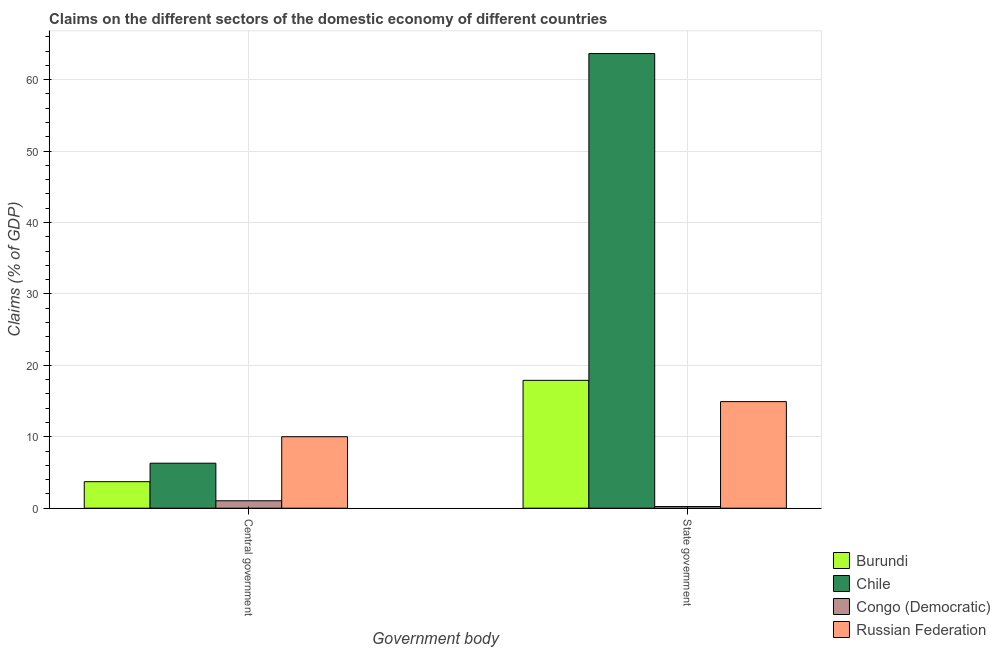How many different coloured bars are there?
Offer a terse response. 4. How many groups of bars are there?
Give a very brief answer. 2. Are the number of bars per tick equal to the number of legend labels?
Provide a short and direct response. Yes. How many bars are there on the 1st tick from the left?
Keep it short and to the point. 4. What is the label of the 1st group of bars from the left?
Ensure brevity in your answer.  Central government. What is the claims on central government in Burundi?
Offer a terse response. 3.71. Across all countries, what is the maximum claims on central government?
Offer a terse response. 10.01. Across all countries, what is the minimum claims on central government?
Give a very brief answer. 1.04. In which country was the claims on central government maximum?
Keep it short and to the point. Russian Federation. In which country was the claims on state government minimum?
Ensure brevity in your answer.  Congo (Democratic). What is the total claims on central government in the graph?
Ensure brevity in your answer.  21.06. What is the difference between the claims on state government in Chile and that in Congo (Democratic)?
Your answer should be very brief. 63.41. What is the difference between the claims on state government in Russian Federation and the claims on central government in Burundi?
Give a very brief answer. 11.21. What is the average claims on state government per country?
Provide a short and direct response. 24.17. What is the difference between the claims on central government and claims on state government in Chile?
Offer a very short reply. -57.34. What is the ratio of the claims on central government in Russian Federation to that in Chile?
Your answer should be very brief. 1.59. In how many countries, is the claims on state government greater than the average claims on state government taken over all countries?
Give a very brief answer. 1. What does the 3rd bar from the left in Central government represents?
Offer a very short reply. Congo (Democratic). What does the 3rd bar from the right in Central government represents?
Offer a very short reply. Chile. Does the graph contain any zero values?
Provide a short and direct response. No. Does the graph contain grids?
Your answer should be very brief. Yes. Where does the legend appear in the graph?
Your answer should be very brief. Bottom right. What is the title of the graph?
Your answer should be very brief. Claims on the different sectors of the domestic economy of different countries. What is the label or title of the X-axis?
Give a very brief answer. Government body. What is the label or title of the Y-axis?
Provide a succinct answer. Claims (% of GDP). What is the Claims (% of GDP) of Burundi in Central government?
Offer a very short reply. 3.71. What is the Claims (% of GDP) of Chile in Central government?
Your answer should be very brief. 6.3. What is the Claims (% of GDP) of Congo (Democratic) in Central government?
Make the answer very short. 1.04. What is the Claims (% of GDP) in Russian Federation in Central government?
Provide a succinct answer. 10.01. What is the Claims (% of GDP) in Burundi in State government?
Your answer should be very brief. 17.9. What is the Claims (% of GDP) of Chile in State government?
Give a very brief answer. 63.64. What is the Claims (% of GDP) of Congo (Democratic) in State government?
Your answer should be compact. 0.23. What is the Claims (% of GDP) of Russian Federation in State government?
Provide a succinct answer. 14.92. Across all Government body, what is the maximum Claims (% of GDP) in Burundi?
Your answer should be compact. 17.9. Across all Government body, what is the maximum Claims (% of GDP) in Chile?
Your answer should be compact. 63.64. Across all Government body, what is the maximum Claims (% of GDP) in Congo (Democratic)?
Provide a short and direct response. 1.04. Across all Government body, what is the maximum Claims (% of GDP) in Russian Federation?
Your answer should be very brief. 14.92. Across all Government body, what is the minimum Claims (% of GDP) of Burundi?
Ensure brevity in your answer.  3.71. Across all Government body, what is the minimum Claims (% of GDP) in Chile?
Your response must be concise. 6.3. Across all Government body, what is the minimum Claims (% of GDP) in Congo (Democratic)?
Provide a succinct answer. 0.23. Across all Government body, what is the minimum Claims (% of GDP) of Russian Federation?
Offer a terse response. 10.01. What is the total Claims (% of GDP) in Burundi in the graph?
Give a very brief answer. 21.61. What is the total Claims (% of GDP) of Chile in the graph?
Provide a short and direct response. 69.94. What is the total Claims (% of GDP) of Congo (Democratic) in the graph?
Provide a succinct answer. 1.27. What is the total Claims (% of GDP) of Russian Federation in the graph?
Your answer should be very brief. 24.93. What is the difference between the Claims (% of GDP) of Burundi in Central government and that in State government?
Offer a very short reply. -14.19. What is the difference between the Claims (% of GDP) in Chile in Central government and that in State government?
Give a very brief answer. -57.34. What is the difference between the Claims (% of GDP) in Congo (Democratic) in Central government and that in State government?
Give a very brief answer. 0.81. What is the difference between the Claims (% of GDP) of Russian Federation in Central government and that in State government?
Offer a very short reply. -4.91. What is the difference between the Claims (% of GDP) of Burundi in Central government and the Claims (% of GDP) of Chile in State government?
Your answer should be very brief. -59.93. What is the difference between the Claims (% of GDP) in Burundi in Central government and the Claims (% of GDP) in Congo (Democratic) in State government?
Ensure brevity in your answer.  3.48. What is the difference between the Claims (% of GDP) of Burundi in Central government and the Claims (% of GDP) of Russian Federation in State government?
Offer a terse response. -11.21. What is the difference between the Claims (% of GDP) in Chile in Central government and the Claims (% of GDP) in Congo (Democratic) in State government?
Offer a very short reply. 6.07. What is the difference between the Claims (% of GDP) of Chile in Central government and the Claims (% of GDP) of Russian Federation in State government?
Your answer should be compact. -8.62. What is the difference between the Claims (% of GDP) of Congo (Democratic) in Central government and the Claims (% of GDP) of Russian Federation in State government?
Offer a terse response. -13.88. What is the average Claims (% of GDP) of Burundi per Government body?
Ensure brevity in your answer.  10.81. What is the average Claims (% of GDP) in Chile per Government body?
Your answer should be very brief. 34.97. What is the average Claims (% of GDP) of Congo (Democratic) per Government body?
Provide a short and direct response. 0.63. What is the average Claims (% of GDP) in Russian Federation per Government body?
Offer a terse response. 12.46. What is the difference between the Claims (% of GDP) in Burundi and Claims (% of GDP) in Chile in Central government?
Provide a succinct answer. -2.59. What is the difference between the Claims (% of GDP) in Burundi and Claims (% of GDP) in Congo (Democratic) in Central government?
Provide a succinct answer. 2.67. What is the difference between the Claims (% of GDP) of Burundi and Claims (% of GDP) of Russian Federation in Central government?
Your answer should be compact. -6.3. What is the difference between the Claims (% of GDP) of Chile and Claims (% of GDP) of Congo (Democratic) in Central government?
Your answer should be compact. 5.26. What is the difference between the Claims (% of GDP) in Chile and Claims (% of GDP) in Russian Federation in Central government?
Your response must be concise. -3.71. What is the difference between the Claims (% of GDP) of Congo (Democratic) and Claims (% of GDP) of Russian Federation in Central government?
Offer a terse response. -8.97. What is the difference between the Claims (% of GDP) in Burundi and Claims (% of GDP) in Chile in State government?
Ensure brevity in your answer.  -45.74. What is the difference between the Claims (% of GDP) in Burundi and Claims (% of GDP) in Congo (Democratic) in State government?
Your response must be concise. 17.67. What is the difference between the Claims (% of GDP) in Burundi and Claims (% of GDP) in Russian Federation in State government?
Provide a succinct answer. 2.98. What is the difference between the Claims (% of GDP) in Chile and Claims (% of GDP) in Congo (Democratic) in State government?
Your answer should be very brief. 63.41. What is the difference between the Claims (% of GDP) of Chile and Claims (% of GDP) of Russian Federation in State government?
Your answer should be compact. 48.73. What is the difference between the Claims (% of GDP) of Congo (Democratic) and Claims (% of GDP) of Russian Federation in State government?
Your answer should be very brief. -14.69. What is the ratio of the Claims (% of GDP) of Burundi in Central government to that in State government?
Offer a terse response. 0.21. What is the ratio of the Claims (% of GDP) of Chile in Central government to that in State government?
Offer a terse response. 0.1. What is the ratio of the Claims (% of GDP) in Congo (Democratic) in Central government to that in State government?
Your response must be concise. 4.51. What is the ratio of the Claims (% of GDP) of Russian Federation in Central government to that in State government?
Your response must be concise. 0.67. What is the difference between the highest and the second highest Claims (% of GDP) in Burundi?
Ensure brevity in your answer.  14.19. What is the difference between the highest and the second highest Claims (% of GDP) in Chile?
Provide a succinct answer. 57.34. What is the difference between the highest and the second highest Claims (% of GDP) in Congo (Democratic)?
Keep it short and to the point. 0.81. What is the difference between the highest and the second highest Claims (% of GDP) of Russian Federation?
Provide a succinct answer. 4.91. What is the difference between the highest and the lowest Claims (% of GDP) in Burundi?
Your answer should be compact. 14.19. What is the difference between the highest and the lowest Claims (% of GDP) in Chile?
Your answer should be very brief. 57.34. What is the difference between the highest and the lowest Claims (% of GDP) in Congo (Democratic)?
Give a very brief answer. 0.81. What is the difference between the highest and the lowest Claims (% of GDP) of Russian Federation?
Provide a succinct answer. 4.91. 